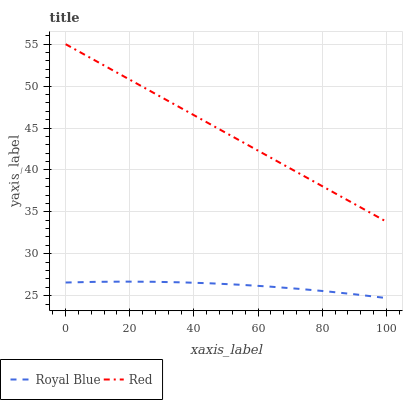Does Royal Blue have the minimum area under the curve?
Answer yes or no. Yes. Does Red have the maximum area under the curve?
Answer yes or no. Yes. Does Red have the minimum area under the curve?
Answer yes or no. No. Is Red the smoothest?
Answer yes or no. Yes. Is Royal Blue the roughest?
Answer yes or no. Yes. Is Red the roughest?
Answer yes or no. No. Does Royal Blue have the lowest value?
Answer yes or no. Yes. Does Red have the lowest value?
Answer yes or no. No. Does Red have the highest value?
Answer yes or no. Yes. Is Royal Blue less than Red?
Answer yes or no. Yes. Is Red greater than Royal Blue?
Answer yes or no. Yes. Does Royal Blue intersect Red?
Answer yes or no. No. 